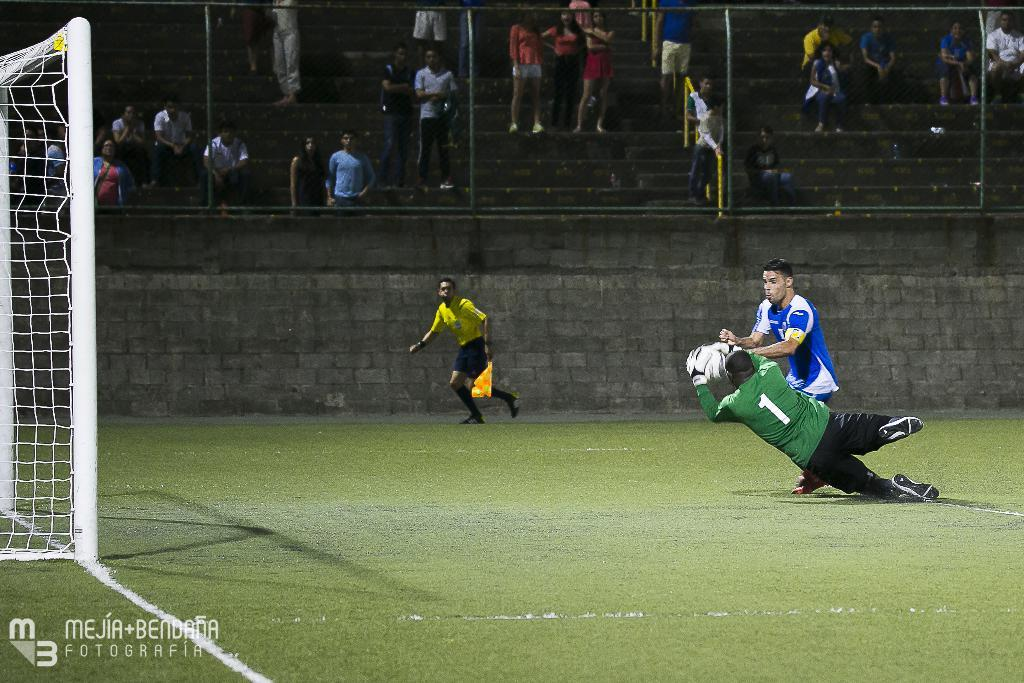Provide a one-sentence caption for the provided image. Number 1 wearing green saves a potential goal by the blue team. 